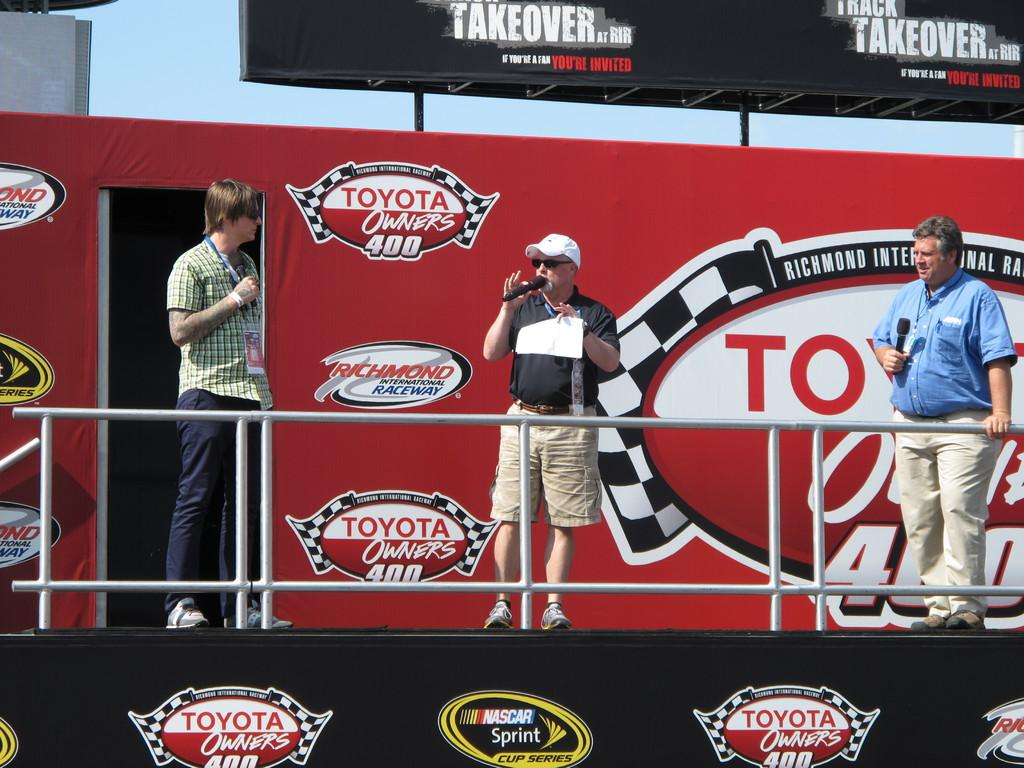<image>
Render a clear and concise summary of the photo. Three men holding microphones stand on stage in front of a sign that says Toyota Owners 400. 